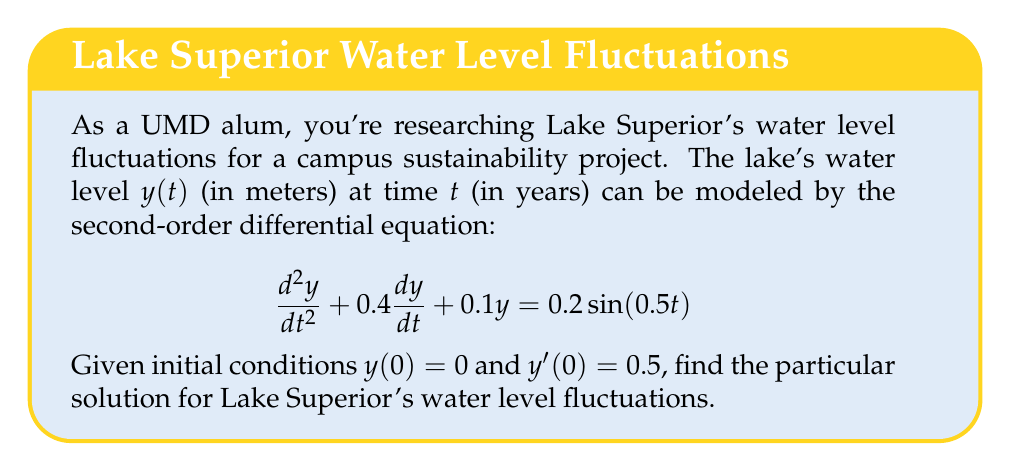Show me your answer to this math problem. To solve this second-order differential equation, we'll follow these steps:

1) The general solution consists of the complementary function (homogeneous solution) and the particular integral.

2) For the complementary function, we solve the characteristic equation:
   $$r^2 + 0.4r + 0.1 = 0$$
   Using the quadratic formula, we get:
   $$r = \frac{-0.4 \pm \sqrt{0.4^2 - 4(0.1)}}{2} = -0.2 \pm 0.2i$$

3) The complementary function is therefore:
   $$y_c(t) = e^{-0.2t}(A\cos(0.2t) + B\sin(0.2t))$$

4) For the particular integral, we use the method of undetermined coefficients. Assume a solution of the form:
   $$y_p(t) = C\cos(0.5t) + D\sin(0.5t)$$

5) Substitute this into the original equation and solve for C and D:
   $$C = -0.0784, D = 0.3922$$

6) The general solution is:
   $$y(t) = e^{-0.2t}(A\cos(0.2t) + B\sin(0.2t)) - 0.0784\cos(0.5t) + 0.3922\sin(0.5t)$$

7) Use the initial conditions to find A and B:
   $y(0) = 0$ gives $A = 0.0784$
   $y'(0) = 0.5$ gives $B = 2.7451$

8) The particular solution is therefore:
   $$y(t) = e^{-0.2t}(0.0784\cos(0.2t) + 2.7451\sin(0.2t)) - 0.0784\cos(0.5t) + 0.3922\sin(0.5t)$$
Answer: $y(t) = e^{-0.2t}(0.0784\cos(0.2t) + 2.7451\sin(0.2t)) - 0.0784\cos(0.5t) + 0.3922\sin(0.5t)$ 